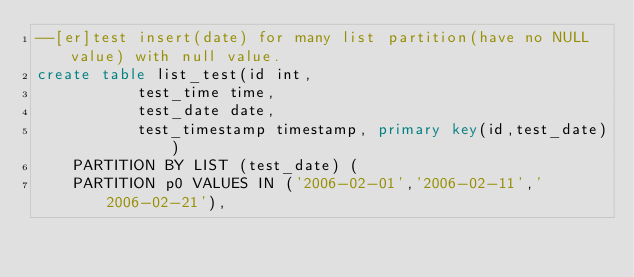Convert code to text. <code><loc_0><loc_0><loc_500><loc_500><_SQL_>--[er]test insert(date) for many list partition(have no NULL value) with null value.
create table list_test(id int,	
				   test_time time,
				   test_date date,
				   test_timestamp timestamp, primary key(id,test_date))
		PARTITION BY LIST (test_date) (
		PARTITION p0 VALUES IN ('2006-02-01','2006-02-11','2006-02-21'),</code> 